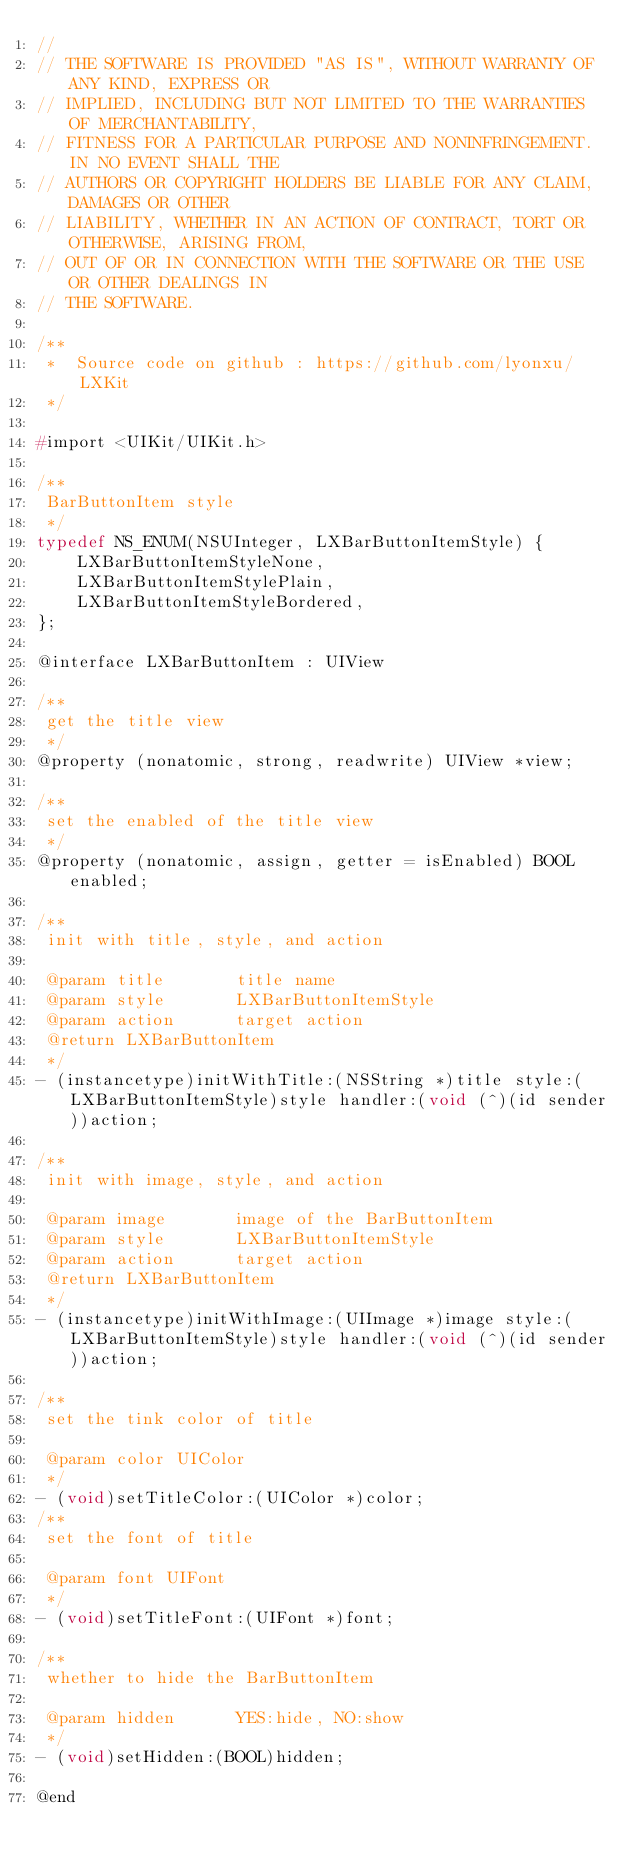<code> <loc_0><loc_0><loc_500><loc_500><_C_>//
// THE SOFTWARE IS PROVIDED "AS IS", WITHOUT WARRANTY OF ANY KIND, EXPRESS OR
// IMPLIED, INCLUDING BUT NOT LIMITED TO THE WARRANTIES OF MERCHANTABILITY,
// FITNESS FOR A PARTICULAR PURPOSE AND NONINFRINGEMENT. IN NO EVENT SHALL THE
// AUTHORS OR COPYRIGHT HOLDERS BE LIABLE FOR ANY CLAIM, DAMAGES OR OTHER
// LIABILITY, WHETHER IN AN ACTION OF CONTRACT, TORT OR OTHERWISE, ARISING FROM,
// OUT OF OR IN CONNECTION WITH THE SOFTWARE OR THE USE OR OTHER DEALINGS IN
// THE SOFTWARE.

/**
 *  Source code on github : https://github.com/lyonxu/LXKit
 */

#import <UIKit/UIKit.h>

/**
 BarButtonItem style
 */
typedef NS_ENUM(NSUInteger, LXBarButtonItemStyle) {
    LXBarButtonItemStyleNone,
    LXBarButtonItemStylePlain,
    LXBarButtonItemStyleBordered,
};

@interface LXBarButtonItem : UIView

/**
 get the title view
 */
@property (nonatomic, strong, readwrite) UIView *view;

/**
 set the enabled of the title view
 */
@property (nonatomic, assign, getter = isEnabled) BOOL enabled;

/**
 init with title, style, and action

 @param title       title name
 @param style       LXBarButtonItemStyle
 @param action      target action
 @return LXBarButtonItem
 */
- (instancetype)initWithTitle:(NSString *)title style:(LXBarButtonItemStyle)style handler:(void (^)(id sender))action;

/**
 init with image, style, and action

 @param image       image of the BarButtonItem
 @param style       LXBarButtonItemStyle
 @param action      target action
 @return LXBarButtonItem
 */
- (instancetype)initWithImage:(UIImage *)image style:(LXBarButtonItemStyle)style handler:(void (^)(id sender))action;

/**
 set the tink color of title

 @param color UIColor
 */
- (void)setTitleColor:(UIColor *)color;
/**
 set the font of title

 @param font UIFont
 */
- (void)setTitleFont:(UIFont *)font;

/**
 whether to hide the BarButtonItem

 @param hidden      YES:hide, NO:show
 */
- (void)setHidden:(BOOL)hidden;

@end
</code> 